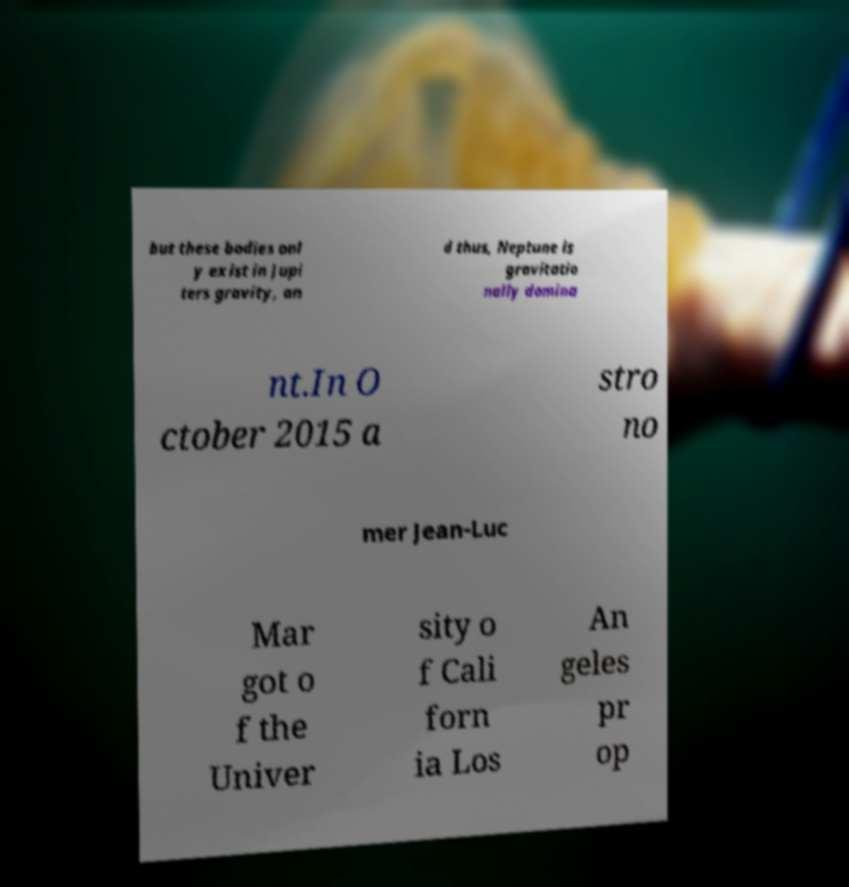What messages or text are displayed in this image? I need them in a readable, typed format. but these bodies onl y exist in Jupi ters gravity, an d thus, Neptune is gravitatio nally domina nt.In O ctober 2015 a stro no mer Jean-Luc Mar got o f the Univer sity o f Cali forn ia Los An geles pr op 